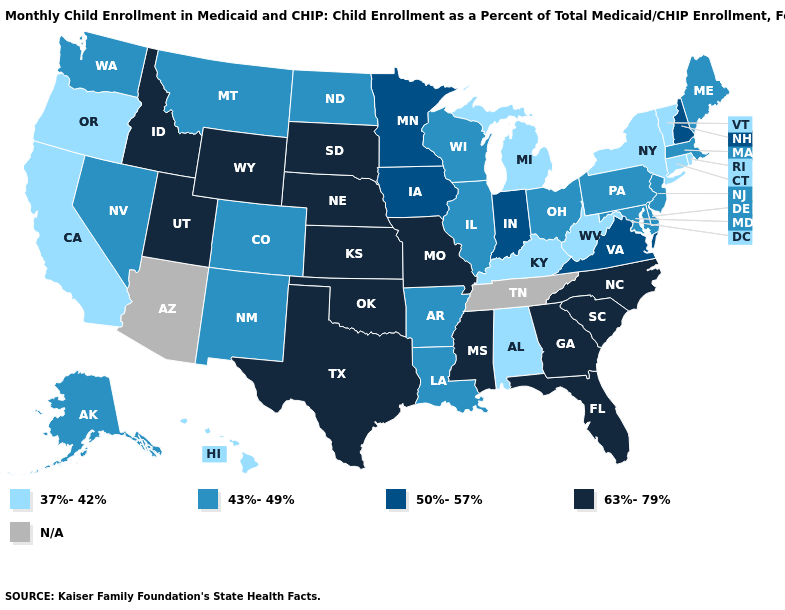Does the map have missing data?
Concise answer only. Yes. Which states have the lowest value in the USA?
Quick response, please. Alabama, California, Connecticut, Hawaii, Kentucky, Michigan, New York, Oregon, Rhode Island, Vermont, West Virginia. Does Wyoming have the lowest value in the USA?
Give a very brief answer. No. What is the value of Missouri?
Write a very short answer. 63%-79%. Name the states that have a value in the range 43%-49%?
Answer briefly. Alaska, Arkansas, Colorado, Delaware, Illinois, Louisiana, Maine, Maryland, Massachusetts, Montana, Nevada, New Jersey, New Mexico, North Dakota, Ohio, Pennsylvania, Washington, Wisconsin. Name the states that have a value in the range 43%-49%?
Answer briefly. Alaska, Arkansas, Colorado, Delaware, Illinois, Louisiana, Maine, Maryland, Massachusetts, Montana, Nevada, New Jersey, New Mexico, North Dakota, Ohio, Pennsylvania, Washington, Wisconsin. What is the highest value in the West ?
Quick response, please. 63%-79%. Name the states that have a value in the range N/A?
Be succinct. Arizona, Tennessee. Name the states that have a value in the range 63%-79%?
Be succinct. Florida, Georgia, Idaho, Kansas, Mississippi, Missouri, Nebraska, North Carolina, Oklahoma, South Carolina, South Dakota, Texas, Utah, Wyoming. What is the value of Pennsylvania?
Be succinct. 43%-49%. Does North Dakota have the highest value in the USA?
Concise answer only. No. What is the value of California?
Give a very brief answer. 37%-42%. Name the states that have a value in the range N/A?
Answer briefly. Arizona, Tennessee. 